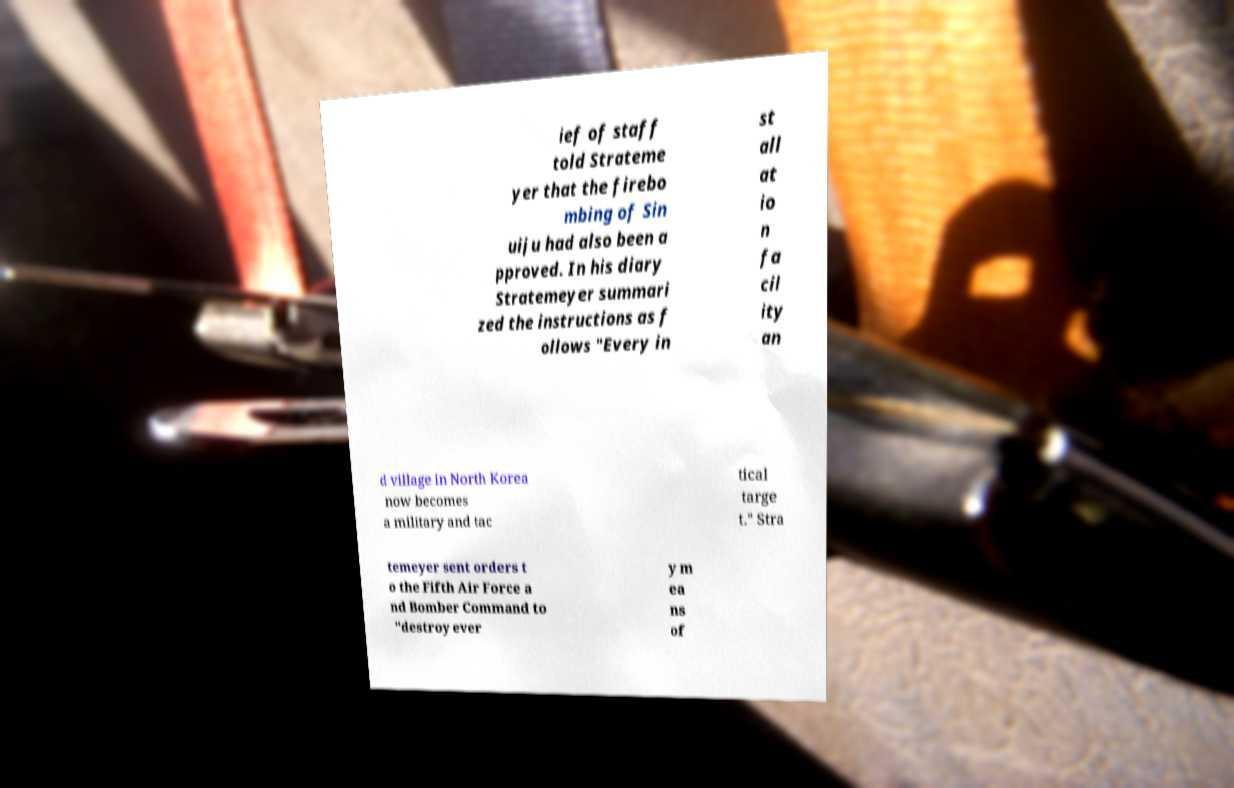Can you read and provide the text displayed in the image?This photo seems to have some interesting text. Can you extract and type it out for me? ief of staff told Strateme yer that the firebo mbing of Sin uiju had also been a pproved. In his diary Stratemeyer summari zed the instructions as f ollows "Every in st all at io n fa cil ity an d village in North Korea now becomes a military and tac tical targe t." Stra temeyer sent orders t o the Fifth Air Force a nd Bomber Command to "destroy ever y m ea ns of 